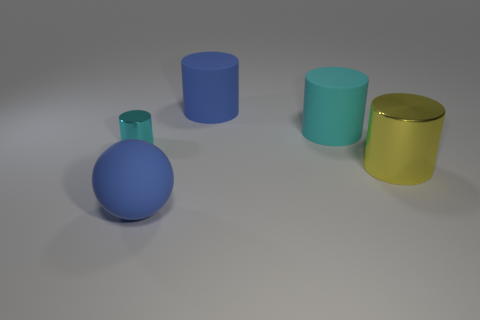There is a metal cylinder on the left side of the yellow metallic thing; is its size the same as the yellow shiny object?
Offer a terse response. No. How many other objects are the same color as the large rubber sphere?
Keep it short and to the point. 1. What is the yellow cylinder made of?
Ensure brevity in your answer.  Metal. The large thing that is both in front of the cyan rubber object and on the left side of the big metallic thing is made of what material?
Your answer should be very brief. Rubber. How many things are either big blue matte objects left of the large blue matte cylinder or small green metallic cubes?
Keep it short and to the point. 1. Is there a yellow cylinder of the same size as the yellow object?
Keep it short and to the point. No. How many blue objects are both in front of the large yellow object and to the right of the blue rubber ball?
Your answer should be very brief. 0. There is a blue rubber cylinder; how many things are on the left side of it?
Keep it short and to the point. 2. Are there any small metal objects that have the same shape as the large cyan rubber thing?
Your response must be concise. Yes. Is the shape of the large yellow object the same as the large blue thing that is behind the tiny cyan shiny object?
Your response must be concise. Yes. 